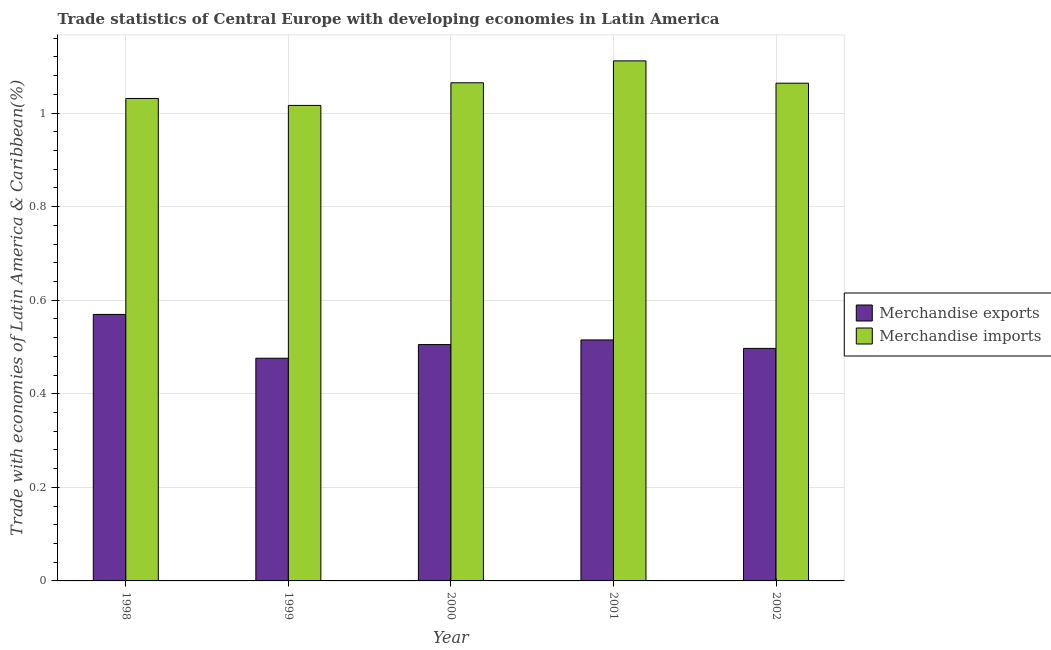How many groups of bars are there?
Keep it short and to the point. 5. Are the number of bars on each tick of the X-axis equal?
Offer a terse response. Yes. In how many cases, is the number of bars for a given year not equal to the number of legend labels?
Your answer should be very brief. 0. What is the merchandise imports in 1998?
Keep it short and to the point. 1.03. Across all years, what is the maximum merchandise exports?
Your answer should be compact. 0.57. Across all years, what is the minimum merchandise imports?
Offer a very short reply. 1.02. In which year was the merchandise exports maximum?
Your answer should be compact. 1998. What is the total merchandise exports in the graph?
Ensure brevity in your answer.  2.56. What is the difference between the merchandise imports in 2000 and that in 2002?
Provide a succinct answer. 0. What is the difference between the merchandise imports in 2000 and the merchandise exports in 1999?
Provide a short and direct response. 0.05. What is the average merchandise imports per year?
Keep it short and to the point. 1.06. What is the ratio of the merchandise imports in 1998 to that in 1999?
Ensure brevity in your answer.  1.01. What is the difference between the highest and the second highest merchandise imports?
Your answer should be very brief. 0.05. What is the difference between the highest and the lowest merchandise imports?
Your response must be concise. 0.1. Is the sum of the merchandise imports in 2000 and 2002 greater than the maximum merchandise exports across all years?
Your response must be concise. Yes. What does the 2nd bar from the left in 1999 represents?
Your answer should be compact. Merchandise imports. How many bars are there?
Provide a short and direct response. 10. What is the difference between two consecutive major ticks on the Y-axis?
Give a very brief answer. 0.2. Are the values on the major ticks of Y-axis written in scientific E-notation?
Give a very brief answer. No. Does the graph contain any zero values?
Provide a short and direct response. No. Where does the legend appear in the graph?
Ensure brevity in your answer.  Center right. What is the title of the graph?
Offer a very short reply. Trade statistics of Central Europe with developing economies in Latin America. Does "Domestic Liabilities" appear as one of the legend labels in the graph?
Offer a very short reply. No. What is the label or title of the X-axis?
Offer a very short reply. Year. What is the label or title of the Y-axis?
Provide a succinct answer. Trade with economies of Latin America & Caribbean(%). What is the Trade with economies of Latin America & Caribbean(%) of Merchandise exports in 1998?
Ensure brevity in your answer.  0.57. What is the Trade with economies of Latin America & Caribbean(%) of Merchandise imports in 1998?
Provide a succinct answer. 1.03. What is the Trade with economies of Latin America & Caribbean(%) in Merchandise exports in 1999?
Your response must be concise. 0.48. What is the Trade with economies of Latin America & Caribbean(%) in Merchandise imports in 1999?
Your answer should be very brief. 1.02. What is the Trade with economies of Latin America & Caribbean(%) in Merchandise exports in 2000?
Provide a succinct answer. 0.51. What is the Trade with economies of Latin America & Caribbean(%) of Merchandise imports in 2000?
Keep it short and to the point. 1.06. What is the Trade with economies of Latin America & Caribbean(%) in Merchandise exports in 2001?
Your answer should be compact. 0.52. What is the Trade with economies of Latin America & Caribbean(%) in Merchandise imports in 2001?
Provide a short and direct response. 1.11. What is the Trade with economies of Latin America & Caribbean(%) of Merchandise exports in 2002?
Offer a very short reply. 0.5. What is the Trade with economies of Latin America & Caribbean(%) in Merchandise imports in 2002?
Keep it short and to the point. 1.06. Across all years, what is the maximum Trade with economies of Latin America & Caribbean(%) of Merchandise exports?
Offer a very short reply. 0.57. Across all years, what is the maximum Trade with economies of Latin America & Caribbean(%) in Merchandise imports?
Keep it short and to the point. 1.11. Across all years, what is the minimum Trade with economies of Latin America & Caribbean(%) of Merchandise exports?
Make the answer very short. 0.48. Across all years, what is the minimum Trade with economies of Latin America & Caribbean(%) in Merchandise imports?
Offer a terse response. 1.02. What is the total Trade with economies of Latin America & Caribbean(%) of Merchandise exports in the graph?
Offer a terse response. 2.56. What is the total Trade with economies of Latin America & Caribbean(%) in Merchandise imports in the graph?
Your response must be concise. 5.29. What is the difference between the Trade with economies of Latin America & Caribbean(%) in Merchandise exports in 1998 and that in 1999?
Ensure brevity in your answer.  0.09. What is the difference between the Trade with economies of Latin America & Caribbean(%) in Merchandise imports in 1998 and that in 1999?
Provide a short and direct response. 0.01. What is the difference between the Trade with economies of Latin America & Caribbean(%) in Merchandise exports in 1998 and that in 2000?
Provide a succinct answer. 0.06. What is the difference between the Trade with economies of Latin America & Caribbean(%) in Merchandise imports in 1998 and that in 2000?
Provide a succinct answer. -0.03. What is the difference between the Trade with economies of Latin America & Caribbean(%) of Merchandise exports in 1998 and that in 2001?
Give a very brief answer. 0.05. What is the difference between the Trade with economies of Latin America & Caribbean(%) of Merchandise imports in 1998 and that in 2001?
Offer a terse response. -0.08. What is the difference between the Trade with economies of Latin America & Caribbean(%) of Merchandise exports in 1998 and that in 2002?
Keep it short and to the point. 0.07. What is the difference between the Trade with economies of Latin America & Caribbean(%) in Merchandise imports in 1998 and that in 2002?
Provide a short and direct response. -0.03. What is the difference between the Trade with economies of Latin America & Caribbean(%) of Merchandise exports in 1999 and that in 2000?
Your response must be concise. -0.03. What is the difference between the Trade with economies of Latin America & Caribbean(%) of Merchandise imports in 1999 and that in 2000?
Keep it short and to the point. -0.05. What is the difference between the Trade with economies of Latin America & Caribbean(%) in Merchandise exports in 1999 and that in 2001?
Ensure brevity in your answer.  -0.04. What is the difference between the Trade with economies of Latin America & Caribbean(%) in Merchandise imports in 1999 and that in 2001?
Offer a terse response. -0.1. What is the difference between the Trade with economies of Latin America & Caribbean(%) of Merchandise exports in 1999 and that in 2002?
Ensure brevity in your answer.  -0.02. What is the difference between the Trade with economies of Latin America & Caribbean(%) in Merchandise imports in 1999 and that in 2002?
Your answer should be compact. -0.05. What is the difference between the Trade with economies of Latin America & Caribbean(%) of Merchandise exports in 2000 and that in 2001?
Keep it short and to the point. -0.01. What is the difference between the Trade with economies of Latin America & Caribbean(%) of Merchandise imports in 2000 and that in 2001?
Your answer should be very brief. -0.05. What is the difference between the Trade with economies of Latin America & Caribbean(%) of Merchandise exports in 2000 and that in 2002?
Offer a very short reply. 0.01. What is the difference between the Trade with economies of Latin America & Caribbean(%) of Merchandise imports in 2000 and that in 2002?
Provide a succinct answer. 0. What is the difference between the Trade with economies of Latin America & Caribbean(%) in Merchandise exports in 2001 and that in 2002?
Your answer should be compact. 0.02. What is the difference between the Trade with economies of Latin America & Caribbean(%) in Merchandise imports in 2001 and that in 2002?
Give a very brief answer. 0.05. What is the difference between the Trade with economies of Latin America & Caribbean(%) of Merchandise exports in 1998 and the Trade with economies of Latin America & Caribbean(%) of Merchandise imports in 1999?
Your answer should be compact. -0.45. What is the difference between the Trade with economies of Latin America & Caribbean(%) in Merchandise exports in 1998 and the Trade with economies of Latin America & Caribbean(%) in Merchandise imports in 2000?
Your answer should be compact. -0.5. What is the difference between the Trade with economies of Latin America & Caribbean(%) in Merchandise exports in 1998 and the Trade with economies of Latin America & Caribbean(%) in Merchandise imports in 2001?
Give a very brief answer. -0.54. What is the difference between the Trade with economies of Latin America & Caribbean(%) of Merchandise exports in 1998 and the Trade with economies of Latin America & Caribbean(%) of Merchandise imports in 2002?
Keep it short and to the point. -0.49. What is the difference between the Trade with economies of Latin America & Caribbean(%) in Merchandise exports in 1999 and the Trade with economies of Latin America & Caribbean(%) in Merchandise imports in 2000?
Your answer should be compact. -0.59. What is the difference between the Trade with economies of Latin America & Caribbean(%) in Merchandise exports in 1999 and the Trade with economies of Latin America & Caribbean(%) in Merchandise imports in 2001?
Keep it short and to the point. -0.64. What is the difference between the Trade with economies of Latin America & Caribbean(%) of Merchandise exports in 1999 and the Trade with economies of Latin America & Caribbean(%) of Merchandise imports in 2002?
Provide a short and direct response. -0.59. What is the difference between the Trade with economies of Latin America & Caribbean(%) of Merchandise exports in 2000 and the Trade with economies of Latin America & Caribbean(%) of Merchandise imports in 2001?
Provide a short and direct response. -0.61. What is the difference between the Trade with economies of Latin America & Caribbean(%) of Merchandise exports in 2000 and the Trade with economies of Latin America & Caribbean(%) of Merchandise imports in 2002?
Keep it short and to the point. -0.56. What is the difference between the Trade with economies of Latin America & Caribbean(%) of Merchandise exports in 2001 and the Trade with economies of Latin America & Caribbean(%) of Merchandise imports in 2002?
Provide a short and direct response. -0.55. What is the average Trade with economies of Latin America & Caribbean(%) of Merchandise exports per year?
Give a very brief answer. 0.51. What is the average Trade with economies of Latin America & Caribbean(%) of Merchandise imports per year?
Ensure brevity in your answer.  1.06. In the year 1998, what is the difference between the Trade with economies of Latin America & Caribbean(%) of Merchandise exports and Trade with economies of Latin America & Caribbean(%) of Merchandise imports?
Your response must be concise. -0.46. In the year 1999, what is the difference between the Trade with economies of Latin America & Caribbean(%) of Merchandise exports and Trade with economies of Latin America & Caribbean(%) of Merchandise imports?
Keep it short and to the point. -0.54. In the year 2000, what is the difference between the Trade with economies of Latin America & Caribbean(%) in Merchandise exports and Trade with economies of Latin America & Caribbean(%) in Merchandise imports?
Your answer should be compact. -0.56. In the year 2001, what is the difference between the Trade with economies of Latin America & Caribbean(%) in Merchandise exports and Trade with economies of Latin America & Caribbean(%) in Merchandise imports?
Provide a short and direct response. -0.6. In the year 2002, what is the difference between the Trade with economies of Latin America & Caribbean(%) of Merchandise exports and Trade with economies of Latin America & Caribbean(%) of Merchandise imports?
Offer a terse response. -0.57. What is the ratio of the Trade with economies of Latin America & Caribbean(%) of Merchandise exports in 1998 to that in 1999?
Make the answer very short. 1.2. What is the ratio of the Trade with economies of Latin America & Caribbean(%) in Merchandise imports in 1998 to that in 1999?
Give a very brief answer. 1.01. What is the ratio of the Trade with economies of Latin America & Caribbean(%) of Merchandise exports in 1998 to that in 2000?
Provide a short and direct response. 1.13. What is the ratio of the Trade with economies of Latin America & Caribbean(%) in Merchandise imports in 1998 to that in 2000?
Offer a terse response. 0.97. What is the ratio of the Trade with economies of Latin America & Caribbean(%) of Merchandise exports in 1998 to that in 2001?
Provide a short and direct response. 1.11. What is the ratio of the Trade with economies of Latin America & Caribbean(%) in Merchandise imports in 1998 to that in 2001?
Your response must be concise. 0.93. What is the ratio of the Trade with economies of Latin America & Caribbean(%) of Merchandise exports in 1998 to that in 2002?
Offer a terse response. 1.15. What is the ratio of the Trade with economies of Latin America & Caribbean(%) of Merchandise imports in 1998 to that in 2002?
Provide a short and direct response. 0.97. What is the ratio of the Trade with economies of Latin America & Caribbean(%) in Merchandise exports in 1999 to that in 2000?
Offer a terse response. 0.94. What is the ratio of the Trade with economies of Latin America & Caribbean(%) in Merchandise imports in 1999 to that in 2000?
Provide a succinct answer. 0.95. What is the ratio of the Trade with economies of Latin America & Caribbean(%) of Merchandise exports in 1999 to that in 2001?
Your answer should be very brief. 0.92. What is the ratio of the Trade with economies of Latin America & Caribbean(%) of Merchandise imports in 1999 to that in 2001?
Give a very brief answer. 0.91. What is the ratio of the Trade with economies of Latin America & Caribbean(%) in Merchandise exports in 1999 to that in 2002?
Keep it short and to the point. 0.96. What is the ratio of the Trade with economies of Latin America & Caribbean(%) in Merchandise imports in 1999 to that in 2002?
Your answer should be compact. 0.96. What is the ratio of the Trade with economies of Latin America & Caribbean(%) in Merchandise exports in 2000 to that in 2001?
Offer a terse response. 0.98. What is the ratio of the Trade with economies of Latin America & Caribbean(%) in Merchandise imports in 2000 to that in 2001?
Your answer should be very brief. 0.96. What is the ratio of the Trade with economies of Latin America & Caribbean(%) in Merchandise exports in 2000 to that in 2002?
Your response must be concise. 1.02. What is the ratio of the Trade with economies of Latin America & Caribbean(%) in Merchandise imports in 2000 to that in 2002?
Provide a short and direct response. 1. What is the ratio of the Trade with economies of Latin America & Caribbean(%) in Merchandise exports in 2001 to that in 2002?
Provide a short and direct response. 1.04. What is the ratio of the Trade with economies of Latin America & Caribbean(%) in Merchandise imports in 2001 to that in 2002?
Make the answer very short. 1.04. What is the difference between the highest and the second highest Trade with economies of Latin America & Caribbean(%) of Merchandise exports?
Make the answer very short. 0.05. What is the difference between the highest and the second highest Trade with economies of Latin America & Caribbean(%) of Merchandise imports?
Provide a succinct answer. 0.05. What is the difference between the highest and the lowest Trade with economies of Latin America & Caribbean(%) of Merchandise exports?
Offer a very short reply. 0.09. What is the difference between the highest and the lowest Trade with economies of Latin America & Caribbean(%) of Merchandise imports?
Keep it short and to the point. 0.1. 